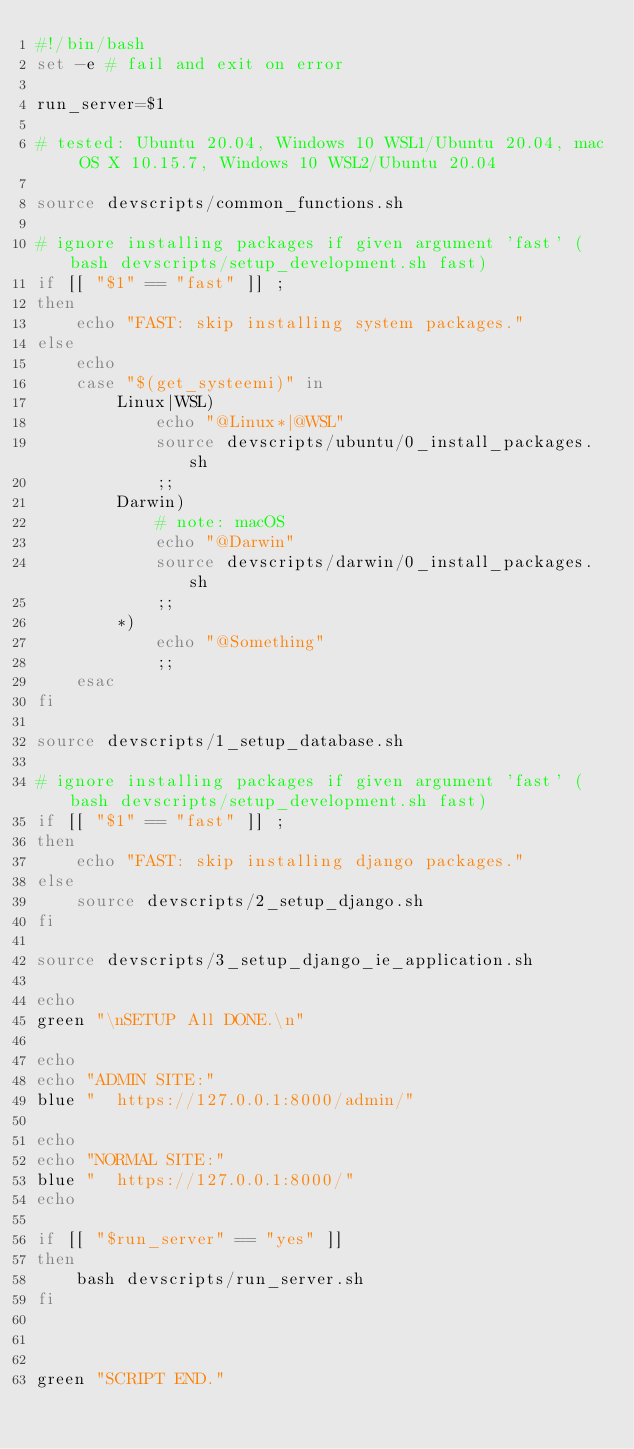<code> <loc_0><loc_0><loc_500><loc_500><_Bash_>#!/bin/bash
set -e # fail and exit on error

run_server=$1

# tested: Ubuntu 20.04, Windows 10 WSL1/Ubuntu 20.04, mac OS X 10.15.7, Windows 10 WSL2/Ubuntu 20.04

source devscripts/common_functions.sh

# ignore installing packages if given argument 'fast' (bash devscripts/setup_development.sh fast)
if [[ "$1" == "fast" ]] ;
then
    echo "FAST: skip installing system packages."
else
    echo
    case "$(get_systeemi)" in
        Linux|WSL)     
            echo "@Linux*|@WSL"
            source devscripts/ubuntu/0_install_packages.sh
            ;;
        Darwin)    
            # note: macOS
            echo "@Darwin"
            source devscripts/darwin/0_install_packages.sh
            ;;
        *)
            echo "@Something"        
            ;;
    esac
fi

source devscripts/1_setup_database.sh

# ignore installing packages if given argument 'fast' (bash devscripts/setup_development.sh fast)
if [[ "$1" == "fast" ]] ;
then
    echo "FAST: skip installing django packages."
else
    source devscripts/2_setup_django.sh
fi

source devscripts/3_setup_django_ie_application.sh

echo
green "\nSETUP All DONE.\n"

echo
echo "ADMIN SITE:"
blue "  https://127.0.0.1:8000/admin/"

echo
echo "NORMAL SITE:"
blue "  https://127.0.0.1:8000/"
echo

if [[ "$run_server" == "yes" ]]
then
    bash devscripts/run_server.sh
fi



green "SCRIPT END."
</code> 